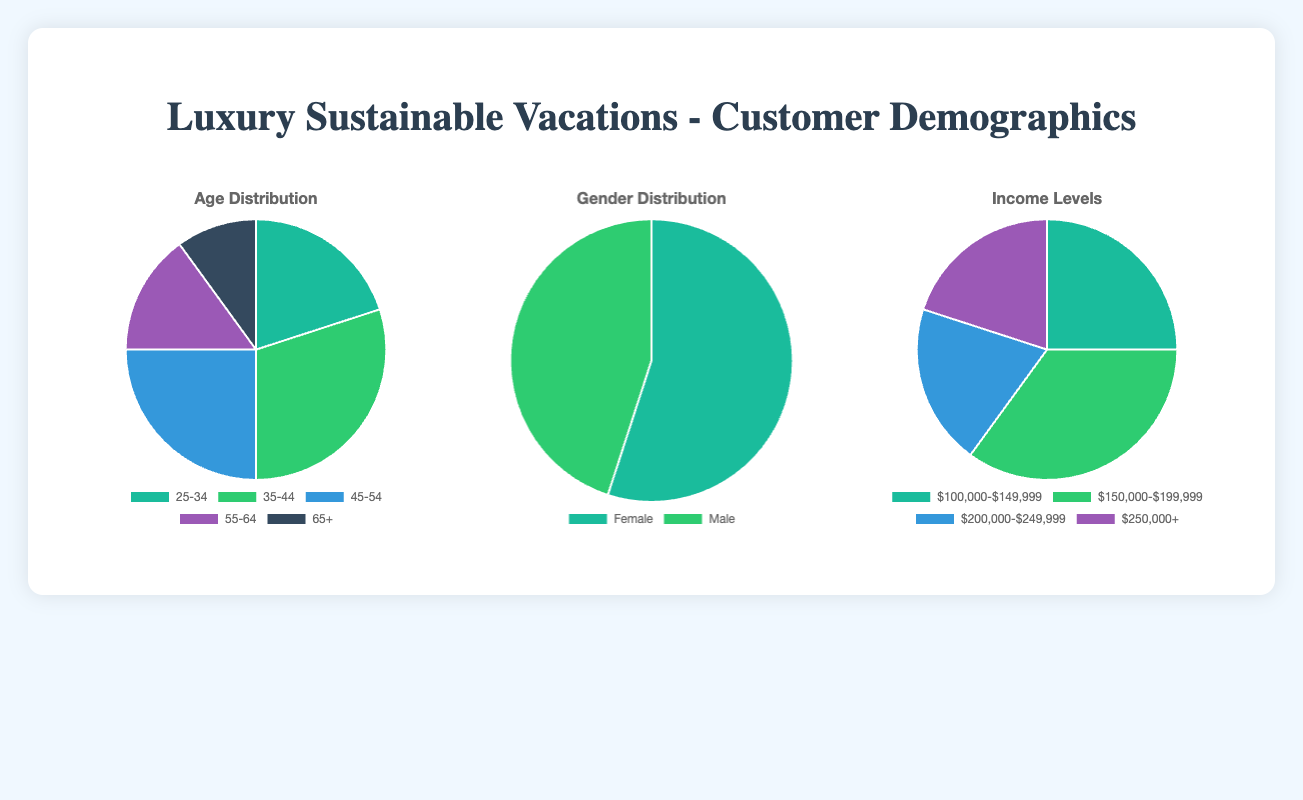What is the most common age group among customers? The age group with the highest percentage of customers is 35-44, as indicated by the largest section of the pie chart.
Answer: 35-44 Which gender is more prevalent among customers, and by what margin? The pie chart shows that females account for 55% of the customers, while males account for 45%. The difference is 10%.
Answer: Females by 10% What percentage of customers fall into the 45-54 and 55-64 age groups combined? The 45-54 age group accounts for 25%, and the 55-64 age group accounts for 15%. Adding these percentages, 25% + 15% = 40%.
Answer: 40% Comparing income levels, which group has the least number of customers? According to the pie chart, the $100,000-$149,999 and $200,000-$249,999 groups each account for 20%, which are the lowest compared to the other income levels.
Answer: $100,000-$149,999 and $200,000-$249,999 Which income level comprises the highest proportion of our customer base? The pie chart indicates that the income level $150,000-$199,999 has the largest slice, which means it has the highest proportion at 35%.
Answer: $150,000-$199,999 What is the combined percentage of customers aged 25-34 and 65+? The age group 25-34 is 20%, and the age group 65+ is 10%. Adding these together, 20% + 10% = 30%.
Answer: 30% Compare the proportions of customers in the 35-44 age group versus the 55-64 age group. By how much is one larger? The 35-44 age group is 30%, and the 55-64 age group is 15%. The difference is 30% - 15% = 15%.
Answer: 15% Which color represents the 25-34 age group in the pie chart? The pie chart displays different colors for each age group. The color corresponding to the 25-34 age bracket is the first slice in the color array, which is green.
Answer: Green What is the most notable trend in the gender distribution of customers? The gender distribution shows a clear majority of female customers at 55%, compared to 45% male customers.
Answer: Majority female 